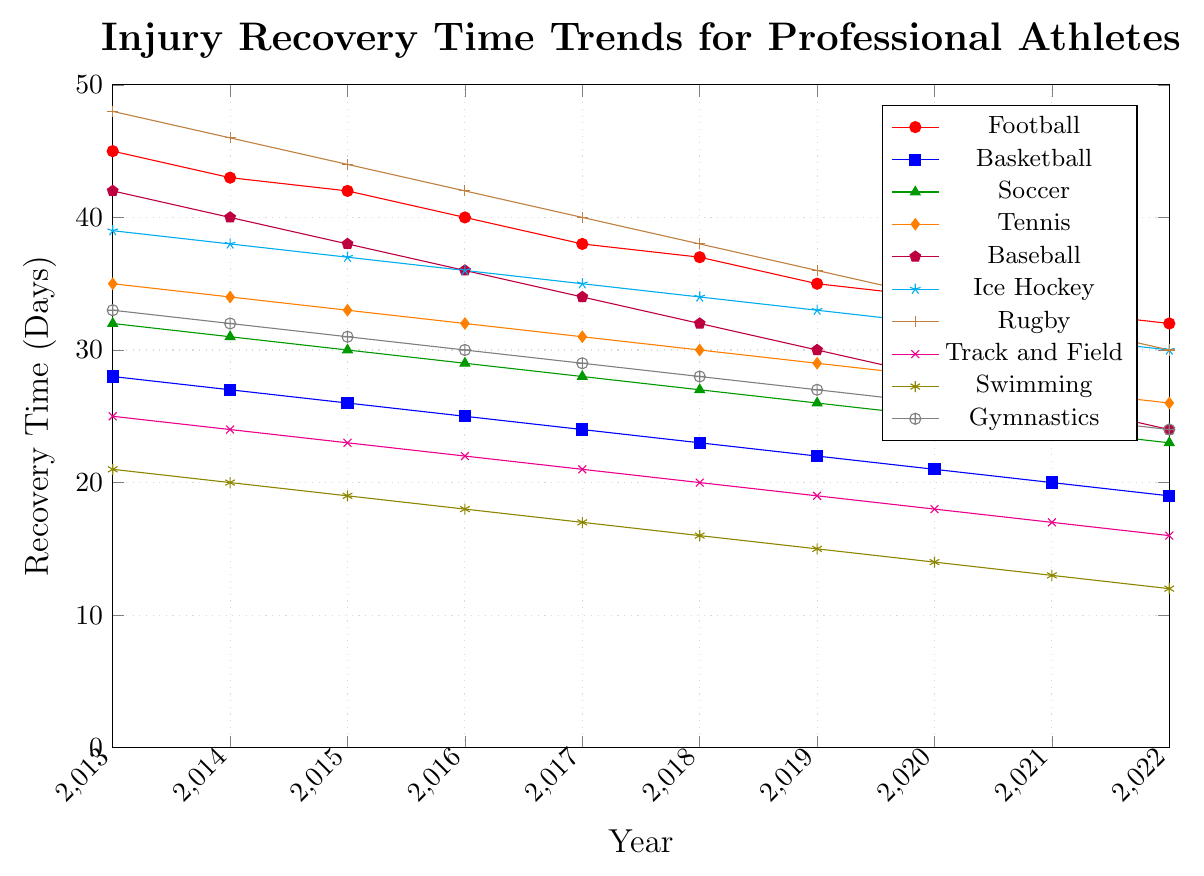What is the overall trend of recovery times for Football from 2013 to 2022? The recovery time for Football consistently decreases each year from 45 days in 2013 to 32 days in 2022, indicating an improvement.
Answer: Decreasing trend Which sport has the highest recovery time in 2022? In 2022, comparing all the data points, Rugby has the highest recovery time of 30 days.
Answer: Rugby Which sport experienced the largest reduction in recovery time from 2013 to 2022? To find the largest reduction, calculate the difference between 2013 and 2022 for each sport: Football (45-32=13), Basketball (28-19=9), Soccer (32-23=9), Tennis (35-26=9), Baseball (42-24=18), Ice Hockey (39-30=9), Rugby (48-30=18), Track and Field (25-16=9), Swimming (21-12=9), Gymnastics (33-24=9). Rugby and Baseball both have a reduction of 18 days.
Answer: Rugby, Baseball Compare the recovery times of Football and Basketball in 2018. Which sport has a shorter duration? In 2018, the recovery time for Football is 37 days, while for Basketball, it is 23 days. Basketball has a shorter duration.
Answer: Basketball What is the average recovery time for Swimming over the years 2013 to 2022? The recovery times for Swimming are [21, 20, 19, 18, 17, 16, 15, 14, 13, 12]. The sum is 165, and there are 10 years. So, the average is 165 / 10 = 16.5
Answer: 16.5 Which sport consistently improved its recovery time every year from 2013 to 2022 without any increase? Reviewing the data for each sport, Soccer shows a consistent decrease each year from 32 days in 2013 to 23 days in 2022.
Answer: Soccer By how many days did the recovery time for Baseball improve from 2013 to 2016? The recovery time for Baseball in 2013 was 42 days, and in 2016, it was 36 days. The improvement is 42 - 36 = 6 days.
Answer: 6 days Between Track and Field and Gymnastics, which sport saw a greater improvement in recovery times over the decade? For Track and Field: 25 days in 2013 to 16 days in 2022 = 9 days improvement. For Gymnastics: 33 days in 2013 to 24 days in 2022 = 9 days improvement. Both saw a 9-day improvement.
Answer: Both equal What is the median recovery time for Ice Hockey over the dataset? The recovery times for Ice Hockey are [39, 38, 37, 36, 35, 34, 33, 32, 31, 30]. The middle values in this sorted set are 34 and 35, so the median is (34 + 35) / 2 = 34.5
Answer: 34.5 In which year did Rugby see the highest improvement in recovery time compared to the previous year? Calculate yearly differences for Rugby: (48-46=2), (46-44=2), (44-42=2), (42-40=2), (40-38=2), (38-36=2), (36-34=2), (34-32=2), (32-30=2). All yearly improvements are 2 days, so there is no single year with a higher improvement.
Answer: None 